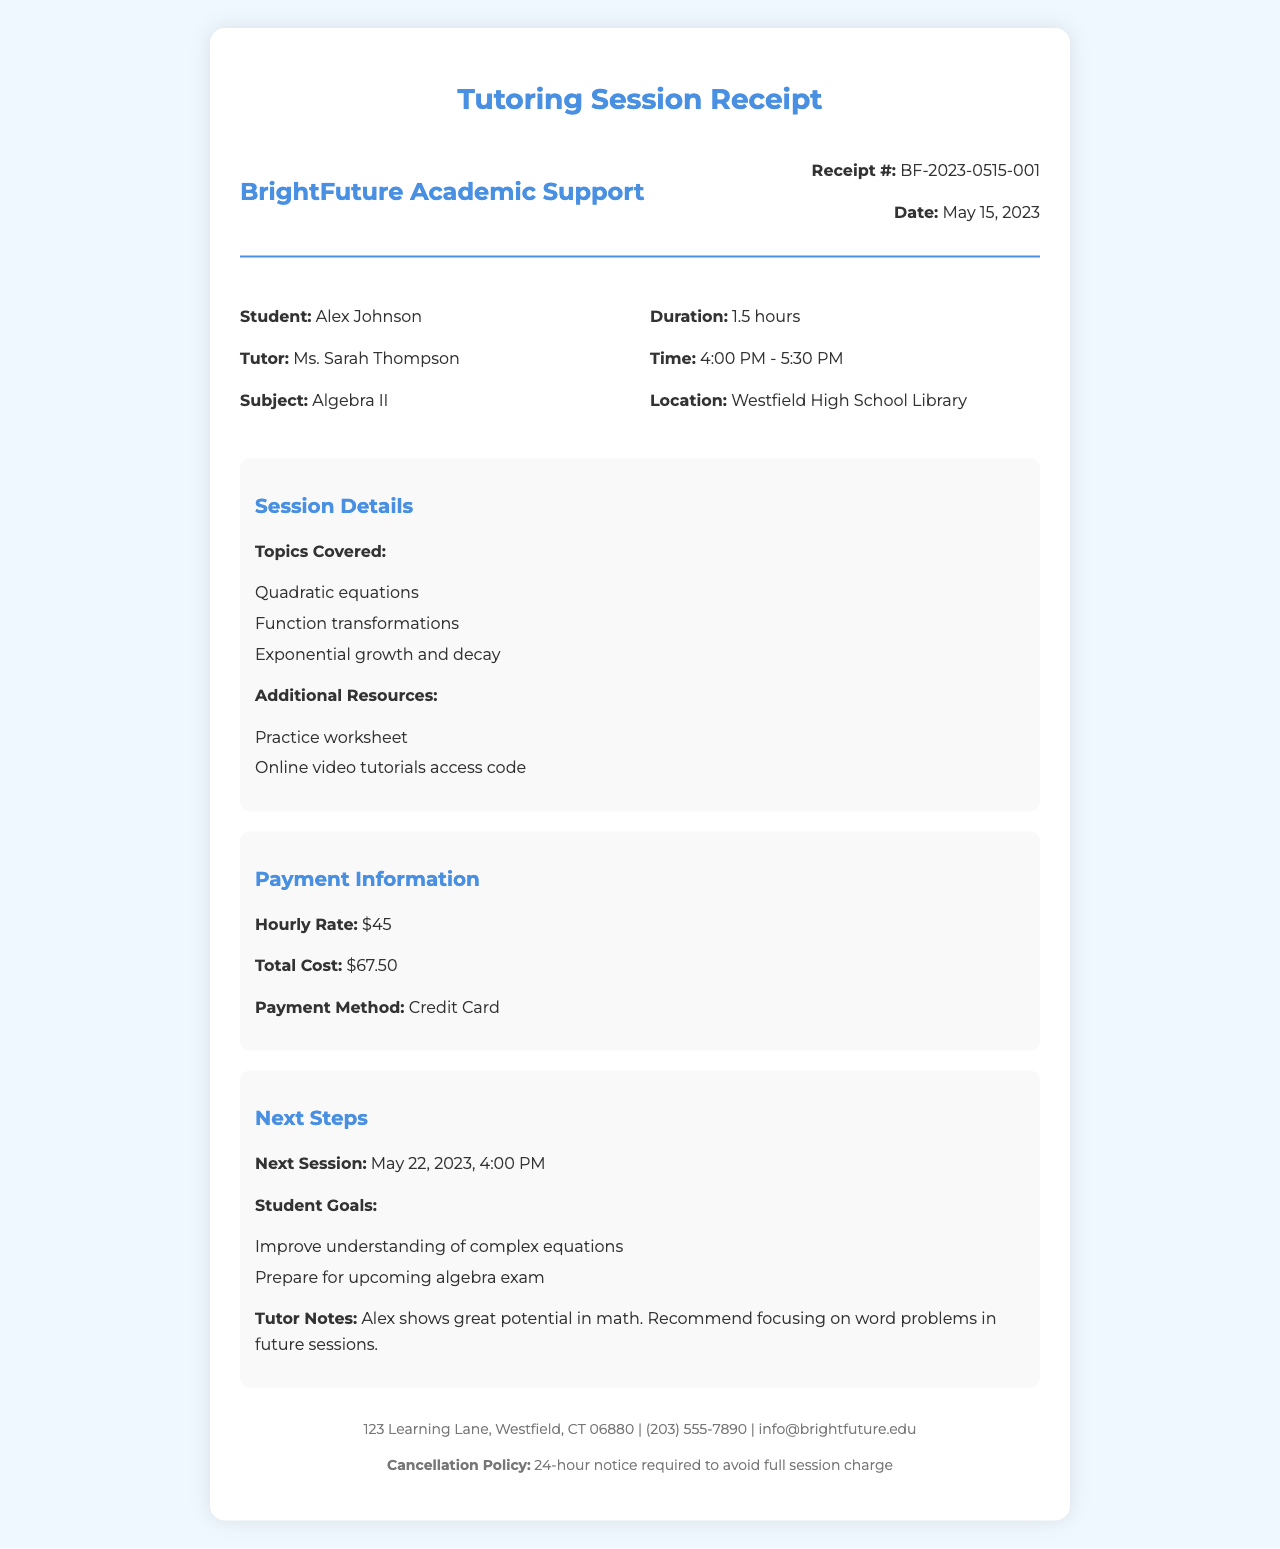What is the name of the tutoring service? The tutoring service name is presented at the top of the receipt as the header.
Answer: BrightFuture Academic Support Who is the tutor for the session? The name of the tutor is stated clearly in the receipt section identifying the tutor for the student.
Answer: Ms. Sarah Thompson What subject was covered during the session? The subject of the tutoring session is explicitly mentioned under the main information section.
Answer: Algebra II What was the total cost of the session? The total cost is displayed in the payment information section.
Answer: $67.50 How long was the tutoring session? The duration of the session is noted in the main information section.
Answer: 1.5 hours What is the cancellation policy? The cancellation policy is specifically stated in the footer portion of the receipt.
Answer: 24-hour notice required to avoid full session charge When is the next session scheduled? The date and time for the next session are listed under the next steps section.
Answer: May 22, 2023, 4:00 PM What was one of the student goals for tutoring? The goals of the student are outlined under the next steps section for clarity.
Answer: Improve understanding of complex equations How was the payment processed for the session? The method by which payment was made is included in the payment information section.
Answer: Credit Card 